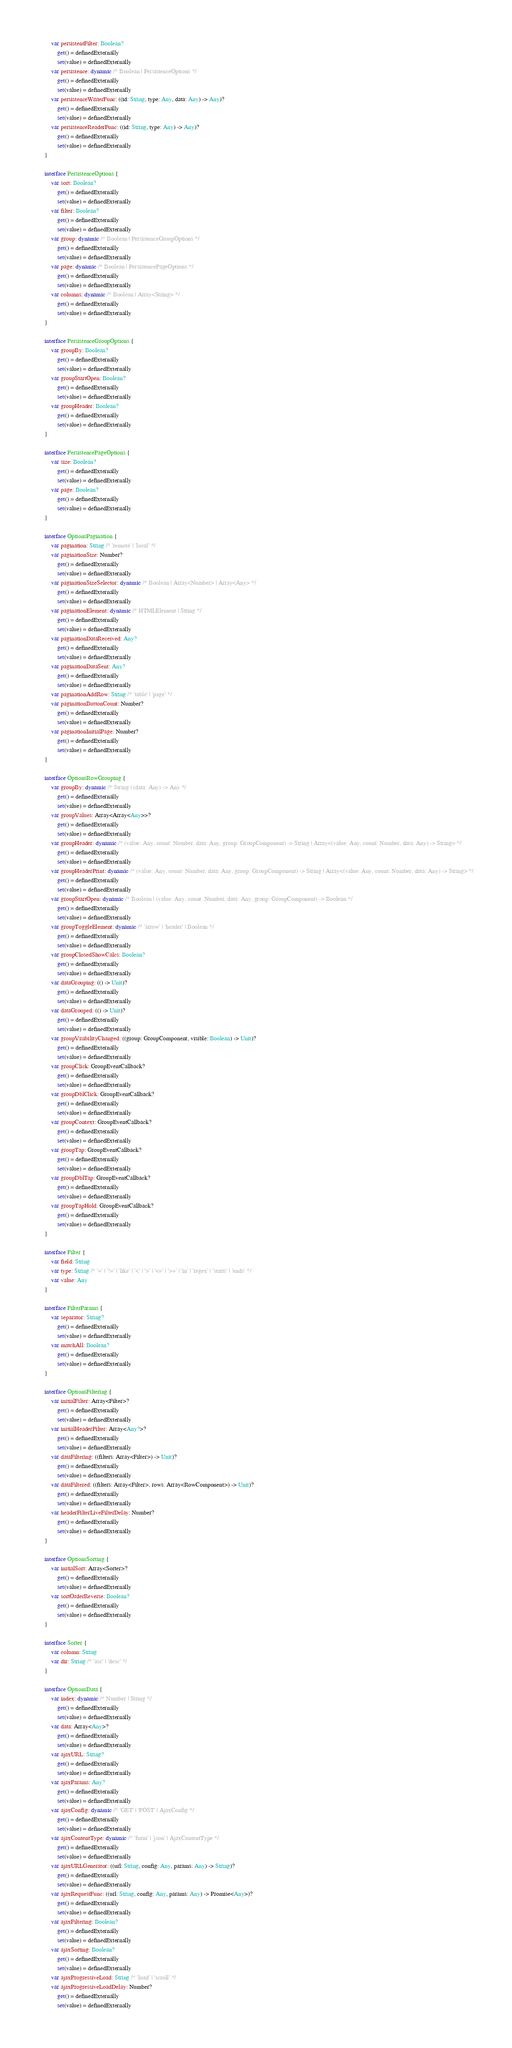<code> <loc_0><loc_0><loc_500><loc_500><_Kotlin_>        var persistentFilter: Boolean?
            get() = definedExternally
            set(value) = definedExternally
        var persistence: dynamic /* Boolean | PersistenceOptions */
            get() = definedExternally
            set(value) = definedExternally
        var persistenceWriterFunc: ((id: String, type: Any, data: Any) -> Any)?
            get() = definedExternally
            set(value) = definedExternally
        var persistenceReaderFunc: ((id: String, type: Any) -> Any)?
            get() = definedExternally
            set(value) = definedExternally
    }

    interface PersistenceOptions {
        var sort: Boolean?
            get() = definedExternally
            set(value) = definedExternally
        var filter: Boolean?
            get() = definedExternally
            set(value) = definedExternally
        var group: dynamic /* Boolean | PersistenceGroupOptions */
            get() = definedExternally
            set(value) = definedExternally
        var page: dynamic /* Boolean | PersistencePageOptions */
            get() = definedExternally
            set(value) = definedExternally
        var columns: dynamic /* Boolean | Array<String> */
            get() = definedExternally
            set(value) = definedExternally
    }

    interface PersistenceGroupOptions {
        var groupBy: Boolean?
            get() = definedExternally
            set(value) = definedExternally
        var groupStartOpen: Boolean?
            get() = definedExternally
            set(value) = definedExternally
        var groupHeader: Boolean?
            get() = definedExternally
            set(value) = definedExternally
    }

    interface PersistencePageOptions {
        var size: Boolean?
            get() = definedExternally
            set(value) = definedExternally
        var page: Boolean?
            get() = definedExternally
            set(value) = definedExternally
    }

    interface OptionsPagination {
        var pagination: String /* 'remote' | 'local' */
        var paginationSize: Number?
            get() = definedExternally
            set(value) = definedExternally
        var paginationSizeSelector: dynamic /* Boolean | Array<Number> | Array<Any> */
            get() = definedExternally
            set(value) = definedExternally
        var paginationElement: dynamic /* HTMLElement | String */
            get() = definedExternally
            set(value) = definedExternally
        var paginationDataReceived: Any?
            get() = definedExternally
            set(value) = definedExternally
        var paginationDataSent: Any?
            get() = definedExternally
            set(value) = definedExternally
        var paginationAddRow: String /* 'table' | 'page' */
        var paginationButtonCount: Number?
            get() = definedExternally
            set(value) = definedExternally
        var paginationInitialPage: Number?
            get() = definedExternally
            set(value) = definedExternally
    }

    interface OptionsRowGrouping {
        var groupBy: dynamic /* String | (data: Any) -> Any */
            get() = definedExternally
            set(value) = definedExternally
        var groupValues: Array<Array<Any>>?
            get() = definedExternally
            set(value) = definedExternally
        var groupHeader: dynamic /* (value: Any, count: Number, data: Any, group: GroupComponent) -> String | Array<(value: Any, count: Number, data: Any) -> String> */
            get() = definedExternally
            set(value) = definedExternally
        var groupHeaderPrint: dynamic /* (value: Any, count: Number, data: Any, group: GroupComponent) -> String | Array<(value: Any, count: Number, data: Any) -> String> */
            get() = definedExternally
            set(value) = definedExternally
        var groupStartOpen: dynamic /* Boolean | (value: Any, count: Number, data: Any, group: GroupComponent) -> Boolean */
            get() = definedExternally
            set(value) = definedExternally
        var groupToggleElement: dynamic /* 'arrow' | 'header' | Boolean */
            get() = definedExternally
            set(value) = definedExternally
        var groupClosedShowCalcs: Boolean?
            get() = definedExternally
            set(value) = definedExternally
        var dataGrouping: (() -> Unit)?
            get() = definedExternally
            set(value) = definedExternally
        var dataGrouped: (() -> Unit)?
            get() = definedExternally
            set(value) = definedExternally
        var groupVisibilityChanged: ((group: GroupComponent, visible: Boolean) -> Unit)?
            get() = definedExternally
            set(value) = definedExternally
        var groupClick: GroupEventCallback?
            get() = definedExternally
            set(value) = definedExternally
        var groupDblClick: GroupEventCallback?
            get() = definedExternally
            set(value) = definedExternally
        var groupContext: GroupEventCallback?
            get() = definedExternally
            set(value) = definedExternally
        var groupTap: GroupEventCallback?
            get() = definedExternally
            set(value) = definedExternally
        var groupDblTap: GroupEventCallback?
            get() = definedExternally
            set(value) = definedExternally
        var groupTapHold: GroupEventCallback?
            get() = definedExternally
            set(value) = definedExternally
    }

    interface Filter {
        var field: String
        var type: String /* '=' | '!=' | 'like' | '<' | '>' | '<=' | '>=' | 'in' | 'regex' | 'starts' | 'ends' */
        var value: Any
    }

    interface FilterParams {
        var separator: String?
            get() = definedExternally
            set(value) = definedExternally
        var matchAll: Boolean?
            get() = definedExternally
            set(value) = definedExternally
    }

    interface OptionsFiltering {
        var initialFilter: Array<Filter>?
            get() = definedExternally
            set(value) = definedExternally
        var initialHeaderFilter: Array<Any?>?
            get() = definedExternally
            set(value) = definedExternally
        var dataFiltering: ((filters: Array<Filter>) -> Unit)?
            get() = definedExternally
            set(value) = definedExternally
        var dataFiltered: ((filters: Array<Filter>, rows: Array<RowComponent>) -> Unit)?
            get() = definedExternally
            set(value) = definedExternally
        var headerFilterLiveFilterDelay: Number?
            get() = definedExternally
            set(value) = definedExternally
    }

    interface OptionsSorting {
        var initialSort: Array<Sorter>?
            get() = definedExternally
            set(value) = definedExternally
        var sortOrderReverse: Boolean?
            get() = definedExternally
            set(value) = definedExternally
    }

    interface Sorter {
        var column: String
        var dir: String /* 'asc' | 'desc' */
    }

    interface OptionsData {
        var index: dynamic /* Number | String */
            get() = definedExternally
            set(value) = definedExternally
        var data: Array<Any>?
            get() = definedExternally
            set(value) = definedExternally
        var ajaxURL: String?
            get() = definedExternally
            set(value) = definedExternally
        var ajaxParams: Any?
            get() = definedExternally
            set(value) = definedExternally
        var ajaxConfig: dynamic /* 'GET' | 'POST' | AjaxConfig */
            get() = definedExternally
            set(value) = definedExternally
        var ajaxContentType: dynamic /* 'form' | 'json' | AjaxContentType */
            get() = definedExternally
            set(value) = definedExternally
        var ajaxURLGenerator: ((url: String, config: Any, params: Any) -> String)?
            get() = definedExternally
            set(value) = definedExternally
        var ajaxRequestFunc: ((url: String, config: Any, params: Any) -> Promise<Any>)?
            get() = definedExternally
            set(value) = definedExternally
        var ajaxFiltering: Boolean?
            get() = definedExternally
            set(value) = definedExternally
        var ajaxSorting: Boolean?
            get() = definedExternally
            set(value) = definedExternally
        var ajaxProgressiveLoad: String /* 'load' | 'scroll' */
        var ajaxProgressiveLoadDelay: Number?
            get() = definedExternally
            set(value) = definedExternally</code> 